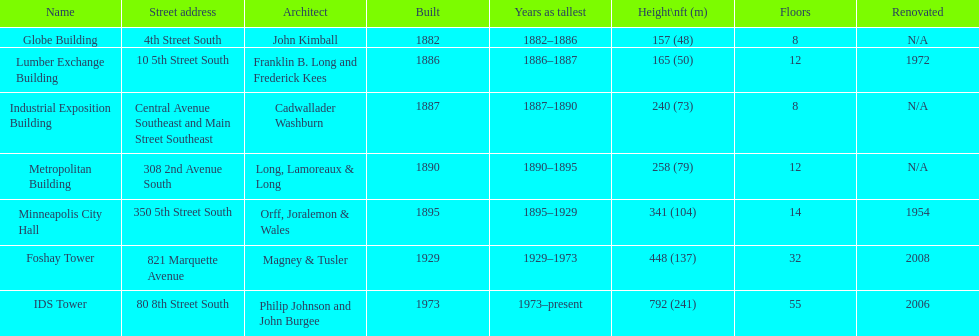How many buildings on the list are taller than 200 feet? 5. 